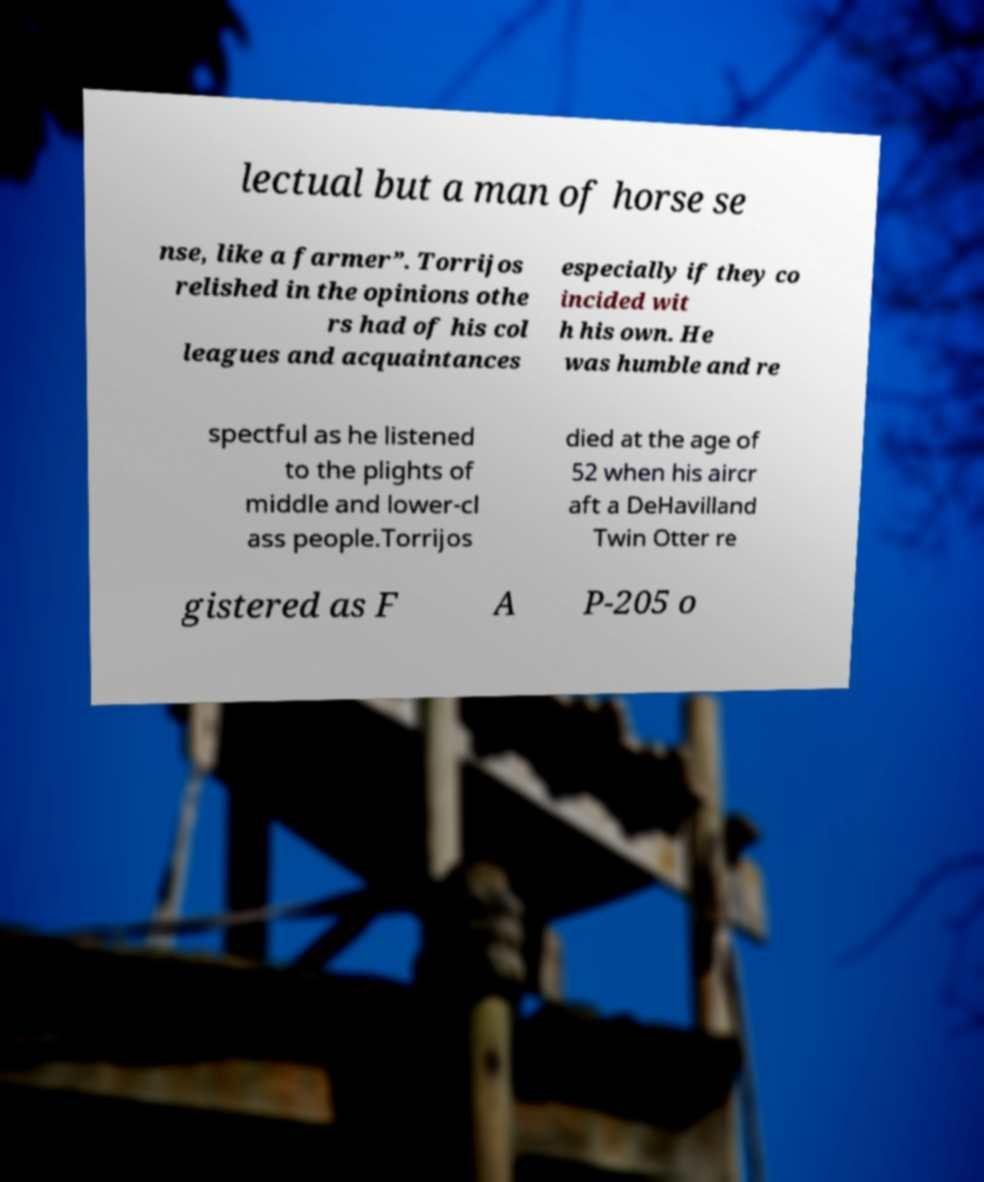I need the written content from this picture converted into text. Can you do that? lectual but a man of horse se nse, like a farmer”. Torrijos relished in the opinions othe rs had of his col leagues and acquaintances especially if they co incided wit h his own. He was humble and re spectful as he listened to the plights of middle and lower-cl ass people.Torrijos died at the age of 52 when his aircr aft a DeHavilland Twin Otter re gistered as F A P-205 o 